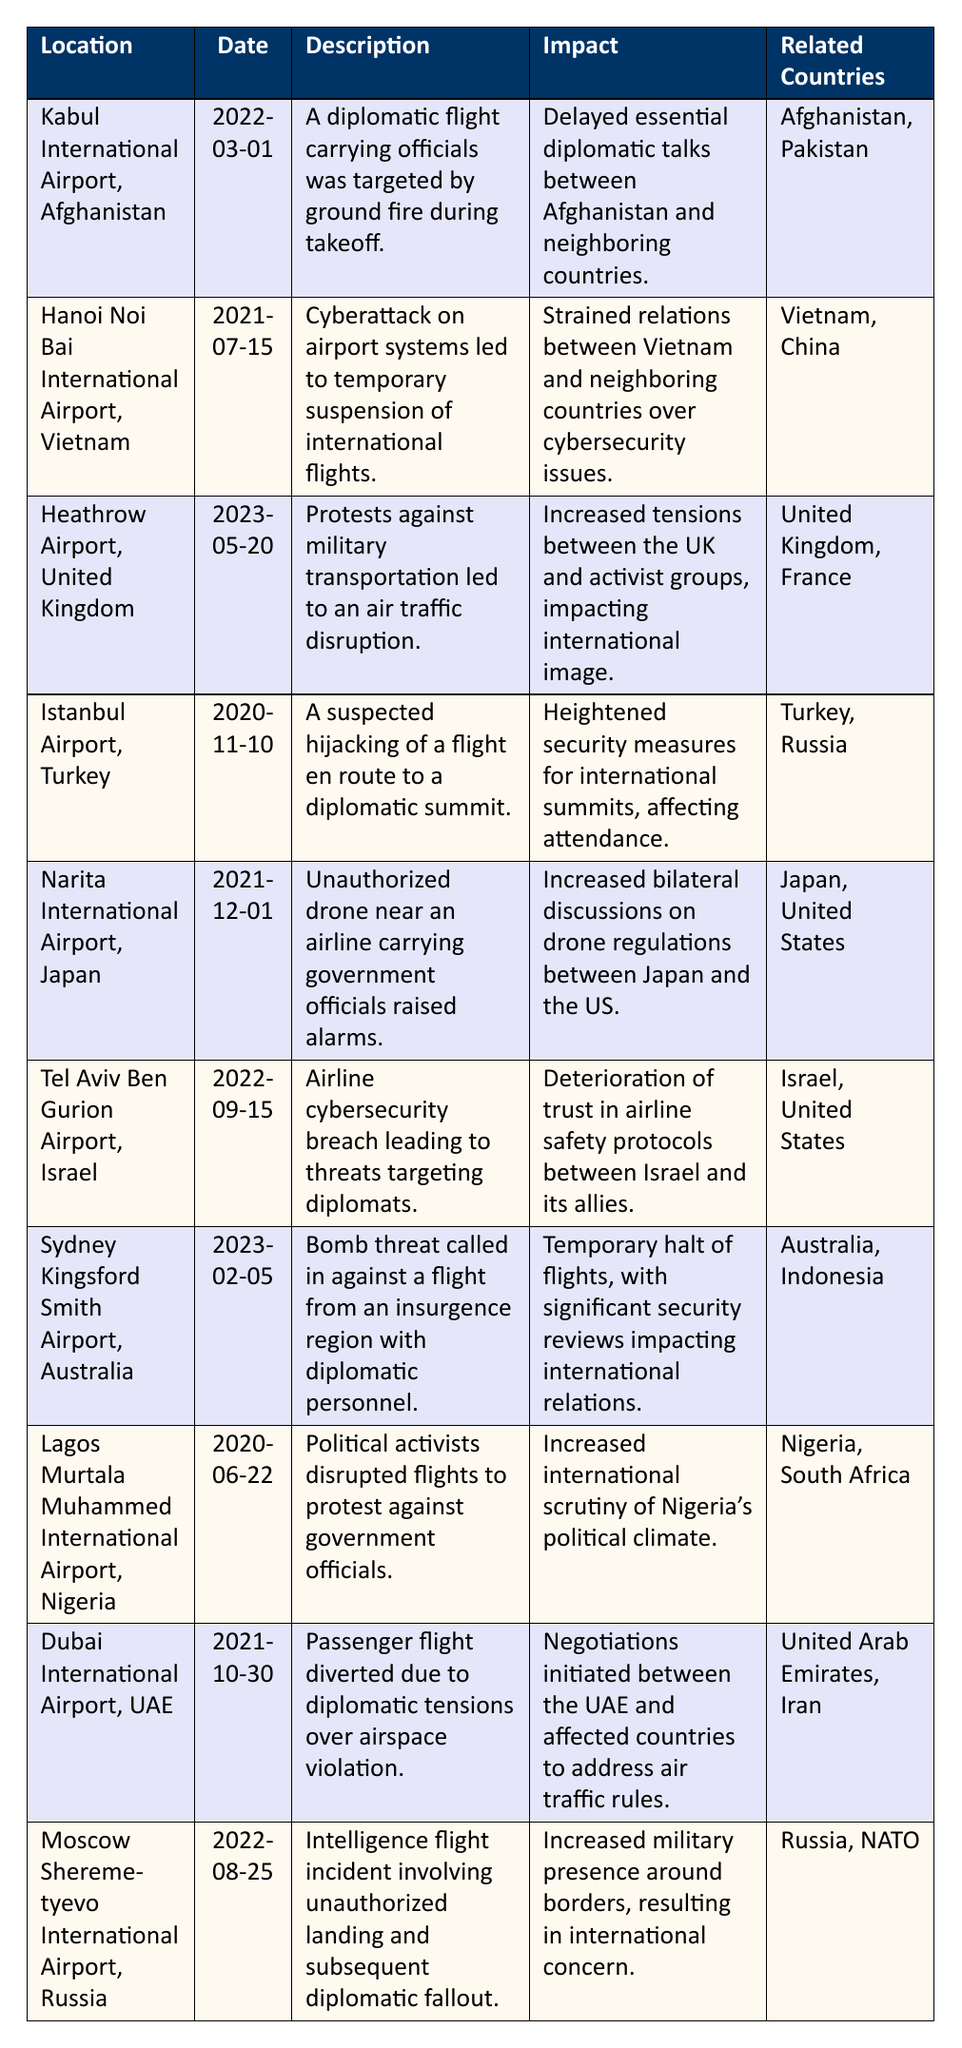What was the incident at Kabul International Airport in March 2022? The table indicates that a diplomatic flight carrying officials was targeted by ground fire during takeoff at Kabul International Airport on March 1, 2022.
Answer: Ground fire on a diplomatic flight Which two countries were involved in the cyberattack incident in Vietnam? According to the table, the cyberattack at Hanoi's Noi Bai International Airport on July 15, 2021, involved Vietnam and China as the related countries.
Answer: Vietnam and China What was the impact of the protests at Heathrow Airport in May 2023? The impact of the protests mentioned on May 20, 2023, at Heathrow Airport led to increased tensions between the UK and activist groups, affecting their international image.
Answer: Increased tensions and impacted image Was there a hijacking incident in Istanbul in November 2020? Yes, the table includes an entry stating that there was a suspected hijacking of a flight en route to a diplomatic summit at Istanbul Airport on November 10, 2020.
Answer: Yes How many incidents involved the United States as a related country? By reviewing the table, we find that there are four incidents involving the United States: incidents 5, 6, 7, and 10, making the total four.
Answer: Four incidents What was the date of the unauthorized drone incident in Japan? The table indicates that the unauthorized drone incident near Narita International Airport occurred on December 1, 2021.
Answer: December 1, 2021 How many incidents listed occurred in 2022? By inspecting the table, we count a total of four incidents that occurred in 2022: incidents 1, 6, 7, and 10.
Answer: Four incidents Which incident had a diplomatic impact due to a bomb threat? The incident at Sydney Kingsford Smith Airport on February 5, 2023, involved a bomb threat against a flight carrying diplomatic personnel, leading to significant security reviews.
Answer: Sydney Kingsford Smith Airport on February 5, 2023 What is the common issue faced by both the incident in Nigeria and the one in the UK? Both incidents, the disruption by political activists in Nigeria on June 22, 2020, and the protests at Heathrow Airport on May 20, 2023, relate to increased scrutiny and tension over political actions impacting international relations.
Answer: Increased scrutiny and political tensions How did the incident at Moscow Sheremetyevo International Airport in August 2022 affect international relations? The unauthorized landing of an intelligence flight at Moscow Sheremetyevo International Airport led to increased military presence around borders, raising international concerns.
Answer: Increased military presence and international concern 